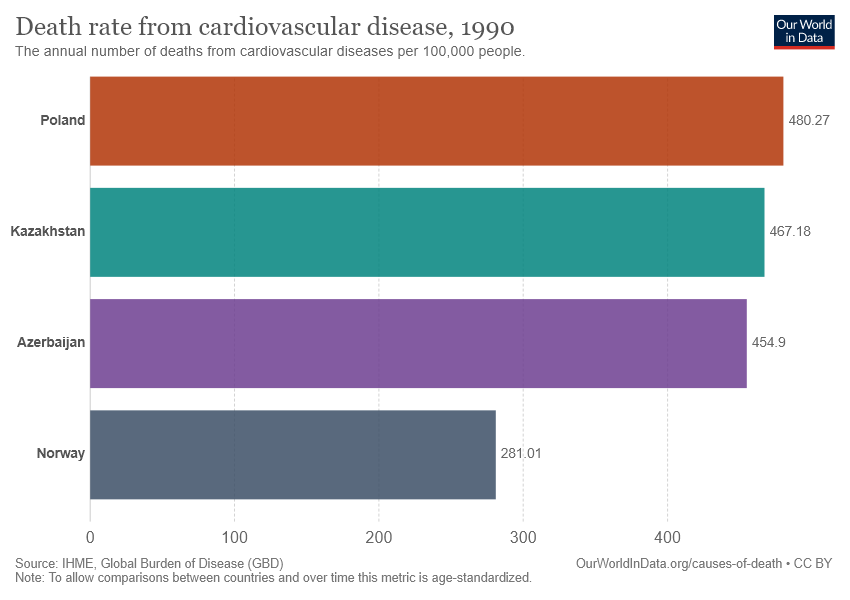Identify some key points in this picture. What is Poland data? It is a numerical value of 480.27...". The size of Poland is approximately 312,679 square kilometers, while the size of Norway is approximately 323,802 square kilometers. Therefore, Poland is approximately 1.709085 times larger than Norway. 